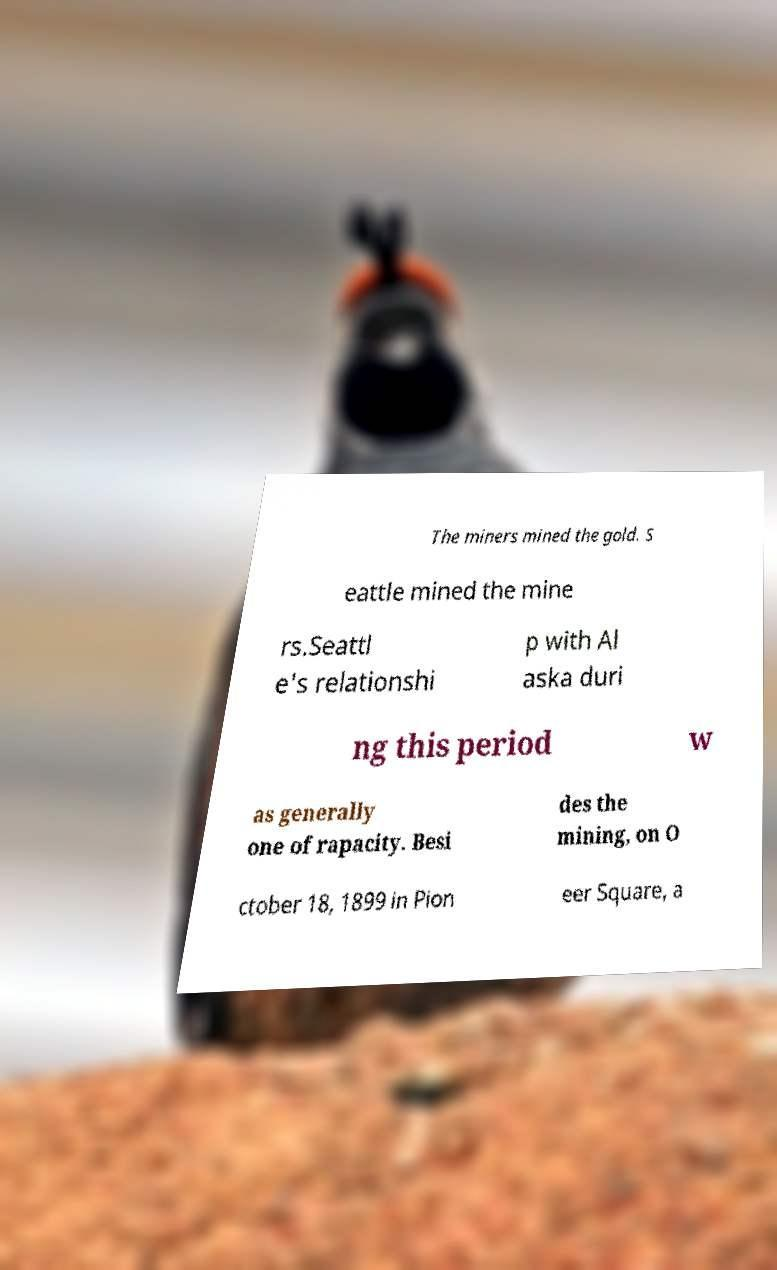Could you assist in decoding the text presented in this image and type it out clearly? The miners mined the gold. S eattle mined the mine rs.Seattl e's relationshi p with Al aska duri ng this period w as generally one of rapacity. Besi des the mining, on O ctober 18, 1899 in Pion eer Square, a 